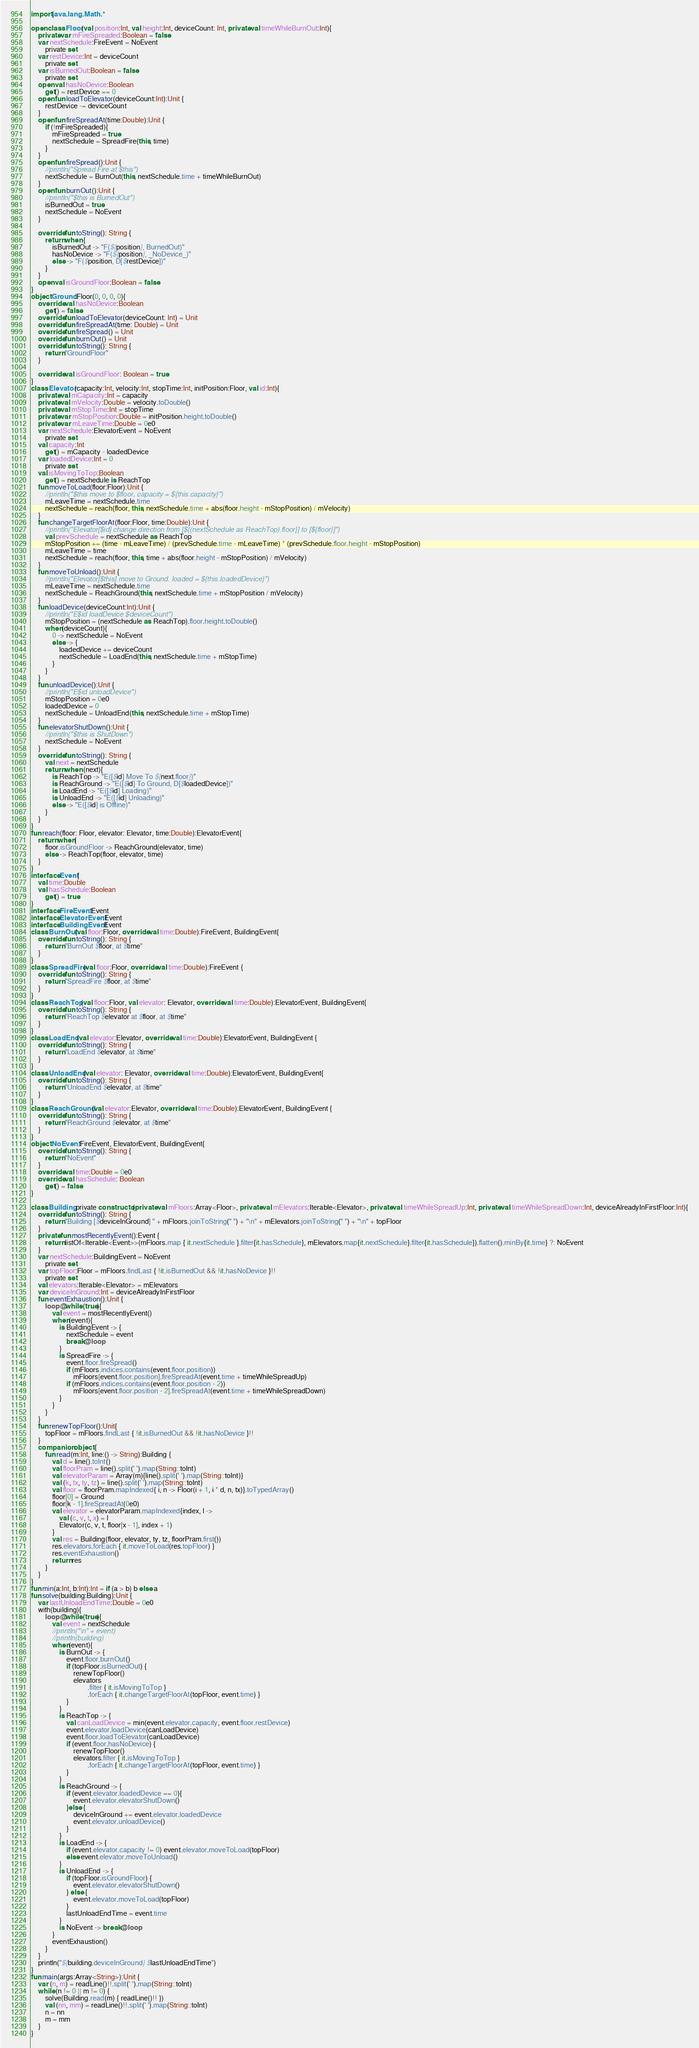<code> <loc_0><loc_0><loc_500><loc_500><_Kotlin_>import java.lang.Math.*

open class Floor(val position:Int, val height:Int, deviceCount: Int, private val timeWhileBurnOut:Int){
    private var mFireSpreaded:Boolean = false
    var nextSchedule:FireEvent = NoEvent
        private set
    var restDevice:Int = deviceCount
        private set
    var isBurnedOut:Boolean = false
        private set
    open val hasNoDevice:Boolean
        get() = restDevice == 0
    open fun loadToElevator(deviceCount:Int):Unit {
        restDevice -= deviceCount
    }
    open fun fireSpreadAt(time:Double):Unit {
        if (!mFireSpreaded){
            mFireSpreaded = true
            nextSchedule = SpreadFire(this, time)
        }
    }
    open fun fireSpread():Unit {
        //println("Spread Fire at $this")
        nextSchedule = BurnOut(this, nextSchedule.time + timeWhileBurnOut)
    }
    open fun burnOut():Unit {
        //println("$this is BurnedOut")
        isBurnedOut = true
        nextSchedule = NoEvent
    }

    override fun toString(): String {
        return when {
            isBurnedOut -> "F(${position}, BurnedOut)"
            hasNoDevice -> "F(${position}, _NoDevice_)"
            else -> "F($position, D[$restDevice])"
        }
    }
    open val isGroundFloor:Boolean = false
}
object Ground:Floor(0, 0, 0, 0){
    override val hasNoDevice:Boolean
        get() = false
    override fun loadToElevator(deviceCount: Int) = Unit
    override fun fireSpreadAt(time: Double) = Unit
    override fun fireSpread() = Unit
    override fun burnOut() = Unit
    override fun toString(): String {
        return "GroundFloor"
    }

    override val isGroundFloor: Boolean = true
}
class Elevator(capacity:Int, velocity:Int, stopTime:Int, initPosition:Floor, val id:Int){
    private val mCapacity:Int = capacity
    private val mVelocity:Double = velocity.toDouble()
    private val mStopTime:Int = stopTime
    private var mStopPosition:Double = initPosition.height.toDouble()
    private var mLeaveTime:Double = 0e0
    var nextSchedule:ElevatorEvent = NoEvent
        private set
    val capacity:Int
        get() = mCapacity - loadedDevice
    var loadedDevice:Int = 0
        private set
    val isMovingToTop:Boolean
        get() = nextSchedule is ReachTop
    fun moveToLoad(floor:Floor):Unit {
        //println("$this move to $floor, capacity = ${this.capacity}")
        mLeaveTime = nextSchedule.time
        nextSchedule = reach(floor, this, nextSchedule.time + abs(floor.height - mStopPosition) / mVelocity)
    }
    fun changeTargetFloorAt(floor:Floor, time:Double):Unit {
        //println("Elevator[$id] change direction from [${(nextSchedule as ReachTop).floor}] to [${floor}]")
        val prevSchedule = nextSchedule as ReachTop
        mStopPosition += (time - mLeaveTime) / (prevSchedule.time - mLeaveTime) * (prevSchedule.floor.height - mStopPosition)
        mLeaveTime = time
        nextSchedule = reach(floor, this, time + abs(floor.height - mStopPosition) / mVelocity)
    }
    fun moveToUnload():Unit {
        //println("Elevator[$this] move to Ground. loaded = ${this.loadedDevice}")
        mLeaveTime = nextSchedule.time
        nextSchedule = ReachGround(this, nextSchedule.time + mStopPosition / mVelocity)
    }
    fun loadDevice(deviceCount:Int):Unit {
        //println("E$id loadDevice $deviceCount")
        mStopPosition = (nextSchedule as ReachTop).floor.height.toDouble()
        when(deviceCount){
            0 -> nextSchedule = NoEvent
            else -> {
                loadedDevice += deviceCount
                nextSchedule = LoadEnd(this, nextSchedule.time + mStopTime)
            }
        }
    }
    fun unloadDevice():Unit {
        //println("E$id unloadDevice")
        mStopPosition = 0e0
        loadedDevice = 0
        nextSchedule = UnloadEnd(this, nextSchedule.time + mStopTime)
    }
    fun elevatorShutDown():Unit {
        //println("$this is ShutDown")
        nextSchedule = NoEvent
    }
    override fun toString(): String {
        val next = nextSchedule
        return when (next){
            is ReachTop -> "E([$id] Move To ${next.floor})"
            is ReachGround -> "E([$id] To Ground, D[$loadedDevice])"
            is LoadEnd -> "E([$id] Loading)"
            is UnloadEnd -> "E([$id] Unloading)"
            else -> "E([$id] is Offline)"
        }
    }
}
fun reach(floor: Floor, elevator: Elevator, time:Double):ElevatorEvent{
    return when{
        floor.isGroundFloor -> ReachGround(elevator, time)
        else -> ReachTop(floor, elevator, time)
    }
}
interface Event{
    val time:Double
    val hasSchedule:Boolean
        get() = true
}
interface FireEvent:Event
interface ElevatorEvent:Event
interface BuildingEvent:Event
class BurnOut(val floor:Floor, override val time:Double):FireEvent, BuildingEvent{
    override fun toString(): String {
        return "BurnOut $floor, at $time"
    }
}
class SpreadFire(val floor:Floor, override val time:Double):FireEvent {
    override fun toString(): String {
        return "SpreadFire $floor, at $time"
    }
}
class ReachTop(val floor:Floor, val elevator: Elevator, override val time:Double):ElevatorEvent, BuildingEvent{
    override fun toString(): String {
        return "ReachTop $elevator at $floor, at $time"
    }
}
class LoadEnd(val elevator:Elevator, override val time:Double):ElevatorEvent, BuildingEvent {
    override fun toString(): String {
        return "LoadEnd $elevator, at $time"
    }
}
class UnloadEnd(val elevator: Elevator, override val time:Double):ElevatorEvent, BuildingEvent{
    override fun toString(): String {
        return "UnloadEnd $elevator, at $time"
    }
}
class ReachGround(val elevator:Elevator, override val time:Double):ElevatorEvent, BuildingEvent {
    override fun toString(): String {
        return "ReachGround $elevator, at $time"
    }
}
object NoEvent:FireEvent, ElevatorEvent, BuildingEvent{
    override fun toString(): String {
        return "NoEvent"
    }
    override val time:Double = 0e0
    override val hasSchedule: Boolean
        get() = false
}

class Building private constructor(private val mFloors:Array<Floor>, private val mElevators:Iterable<Elevator>, private val timeWhileSpreadUp:Int, private val timeWhileSpreadDown:Int, deviceAlreadyInFirstFloor:Int){
    override fun toString(): String {
        return "Building [$deviceInGround] " + mFloors.joinToString(" ") + "\n" + mElevators.joinToString(" ") + "\n" + topFloor
    }
    private fun mostRecentlyEvent():Event {
        return listOf<Iterable<Event>>(mFloors.map { it.nextSchedule }.filter{it.hasSchedule}, mElevators.map{it.nextSchedule}.filter{it.hasSchedule}).flatten().minBy{it.time} ?: NoEvent
    }
    var nextSchedule:BuildingEvent = NoEvent
        private set
    var topFloor:Floor = mFloors.findLast { !it.isBurnedOut && !it.hasNoDevice }!!
        private set
    val elevators:Iterable<Elevator> = mElevators
    var deviceInGround:Int = deviceAlreadyInFirstFloor
    fun eventExhaustion():Unit {
        loop@while (true){
            val event = mostRecentlyEvent()
            when(event){
                is BuildingEvent -> {
                    nextSchedule = event
                    break@loop
                }
                is SpreadFire -> {
                    event.floor.fireSpread()
                    if (mFloors.indices.contains(event.floor.position))
                        mFloors[event.floor.position].fireSpreadAt(event.time + timeWhileSpreadUp)
                    if (mFloors.indices.contains(event.floor.position - 2))
                        mFloors[event.floor.position - 2].fireSpreadAt(event.time + timeWhileSpreadDown)
                }
            }
        }
    }
    fun renewTopFloor():Unit{
        topFloor = mFloors.findLast { !it.isBurnedOut && !it.hasNoDevice }!!
    }
    companion object {
        fun read(m:Int, line:() -> String):Building {
            val d = line().toInt()
            val floorPram = line().split(' ').map(String::toInt)
            val elevatorParam = Array(m){line().split(' ').map(String::toInt)}
            val (k, tx, ty, tz) = line().split(' ').map(String::toInt)
            val floor = floorPram.mapIndexed{ i, n -> Floor(i + 1, i * d, n, tx)}.toTypedArray()
            floor[0] = Ground
            floor[k - 1].fireSpreadAt(0e0)
            val elevator = elevatorParam.mapIndexed{index, l ->
                val (c, v, t, x) = l
                Elevator(c, v, t, floor[x - 1], index + 1)
            }
            val res = Building(floor, elevator, ty, tz, floorPram.first())
            res.elevators.forEach { it.moveToLoad(res.topFloor) }
            res.eventExhaustion()
            return res
        }
    }
}
fun min(a:Int, b:Int):Int = if (a > b) b else a
fun solve(building:Building):Unit {
    var lastUnloadEndTime:Double = 0e0
    with(building){
        loop@while (true){
            val event = nextSchedule
            //println("\n" + event)
            //println(building)
            when(event){
                is BurnOut -> {
                    event.floor.burnOut()
                    if (topFloor.isBurnedOut) {
                        renewTopFloor()
                        elevators
                                .filter { it.isMovingToTop }
                                .forEach { it.changeTargetFloorAt(topFloor, event.time) }
                    }
                }
                is ReachTop -> {
                    val canLoadDevice = min(event.elevator.capacity, event.floor.restDevice)
                    event.elevator.loadDevice(canLoadDevice)
                    event.floor.loadToElevator(canLoadDevice)
                    if (event.floor.hasNoDevice) {
                        renewTopFloor()
                        elevators.filter { it.isMovingToTop }
                                .forEach { it.changeTargetFloorAt(topFloor, event.time) }
                    }
                }
                is ReachGround -> {
                    if (event.elevator.loadedDevice == 0){
                        event.elevator.elevatorShutDown()
                    }else {
                        deviceInGround += event.elevator.loadedDevice
                        event.elevator.unloadDevice()
                    }
                }
                is LoadEnd -> {
                    if (event.elevator.capacity != 0) event.elevator.moveToLoad(topFloor)
                    else event.elevator.moveToUnload()
                }
                is UnloadEnd -> {
                    if (topFloor.isGroundFloor) {
                        event.elevator.elevatorShutDown()
                    } else {
                        event.elevator.moveToLoad(topFloor)
                    }
                    lastUnloadEndTime = event.time
                }
                is NoEvent -> break@loop
            }
            eventExhaustion()
        }
    }
    println("${building.deviceInGround} $lastUnloadEndTime")
}
fun main(args:Array<String>):Unit {
    var (n, m) = readLine()!!.split(' ').map(String::toInt)
    while (n != 0 || m != 0) {
        solve(Building.read(m) { readLine()!! })
        val (nn, mm) = readLine()!!.split(' ').map(String::toInt)
        n = nn
        m = mm
    }
}
</code> 